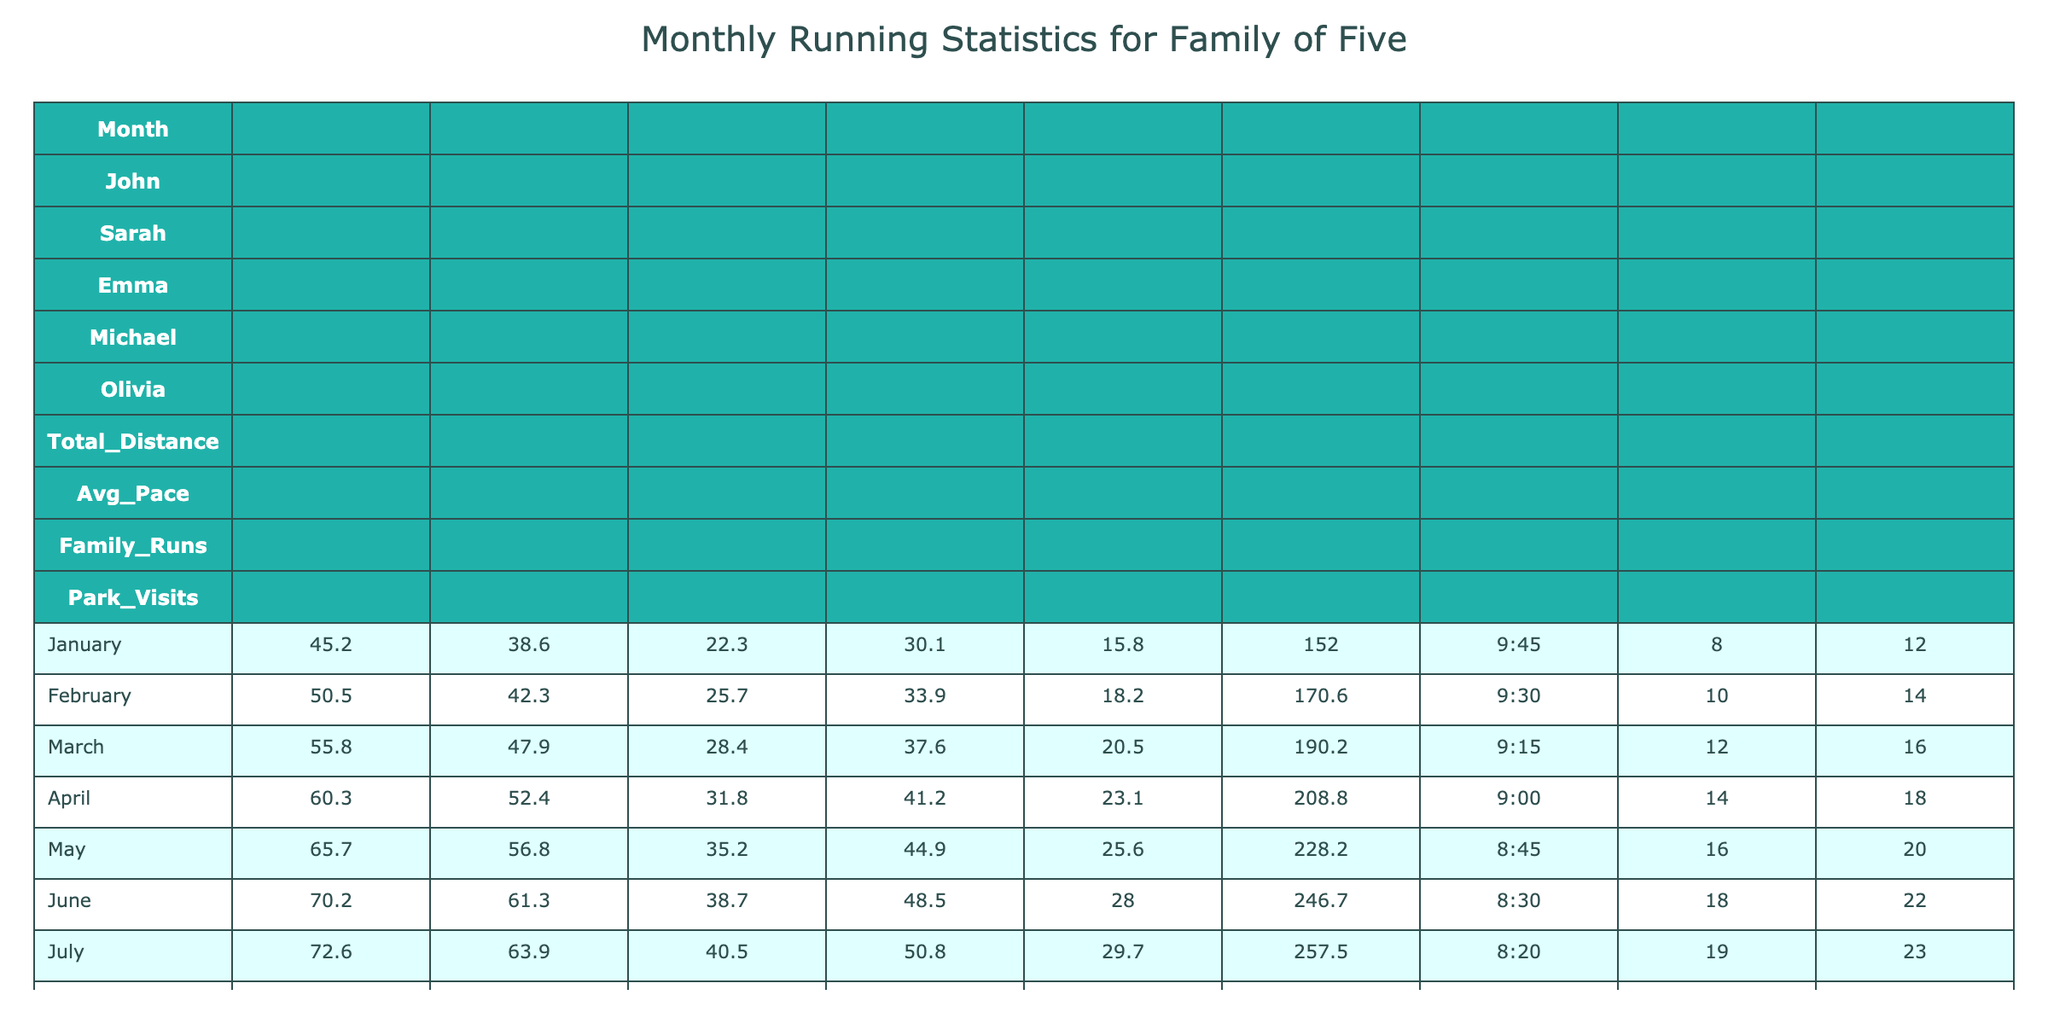What was the total distance run by Emma in March? In March, Emma ran a total distance of 28.4.
Answer: 28.4 In which month did the family run the most total distance? The family ran the most total distance in June with 246.7.
Answer: June What is the average pace of Michael during the year? To find the average pace, convert the paces into minutes per mile and compute the average: (9:45, 9:30, 9:15, 9:00, 8:45, 8:30, 8:20, 8:40, 8:55, 9:10, 9:25, 9:40) corresponds to (585, 570, 555, 540, 525, 510, 500, 520, 535, 550, 565, 580). The average pace in minutes is (585 + 570 + 555 + 540 + 525 + 510 + 500 + 520 + 535 + 550 + 565 + 580) / 12 = 549.16667, which translates back to 9:09 approximately.
Answer: 9:09 Which family member had the least total distance in October? In October, Olivia ran a total distance of 22.3, which is the least of all family members.
Answer: Olivia How much more distance did John run in May compared to January? The distance run by John in May was 65.7 and in January was 45.2. The difference is 65.7 - 45.2 = 20.5.
Answer: 20.5 Did the total distance run by the family decrease from July to August? In July, the total distance was 257.5 and in August it was 241.7, indicating a decrease.
Answer: Yes What is the median average pace of all family members in April? The average paces in April for all members (in minutes) are (9:00 converted to 540, 9:00, 9:00, 9:00, 9:00). The median of these values is 9:00.
Answer: 9:00 Which month had the highest number of family runs? The highest number of family runs occurred in July with 19 runs.
Answer: July If we look at the total distances run each month, which month's total shows more than 200 miles? The months where the total distance exceeds 200 miles are June (246.7), July (257.5), and August (241.7).
Answer: June, July, August What was the change in total distance from November to December? The total distance in November was 184.8 and in December it was 163.9. The change is 163.9 - 184.8 = -20.9.
Answer: -20.9 